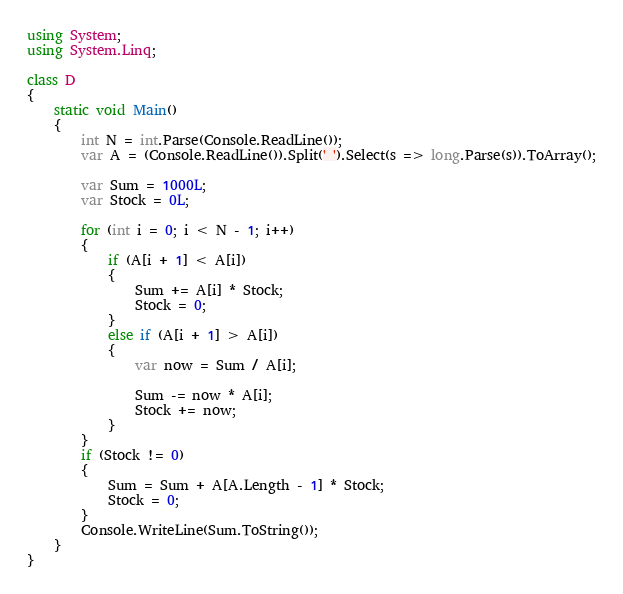<code> <loc_0><loc_0><loc_500><loc_500><_C#_>using System;
using System.Linq;
 
class D
{
    static void Main()
    {
        int N = int.Parse(Console.ReadLine());
        var A = (Console.ReadLine()).Split(' ').Select(s => long.Parse(s)).ToArray();

        var Sum = 1000L;
        var Stock = 0L;

        for (int i = 0; i < N - 1; i++)
        {
            if (A[i + 1] < A[i])
            {
                Sum += A[i] * Stock;
                Stock = 0;
            }
            else if (A[i + 1] > A[i])
            {
                var now = Sum / A[i];
                
                Sum -= now * A[i];
                Stock += now;
            }
        }
        if (Stock != 0)
        {
            Sum = Sum + A[A.Length - 1] * Stock;
            Stock = 0;
        }
        Console.WriteLine(Sum.ToString());
    }
}</code> 